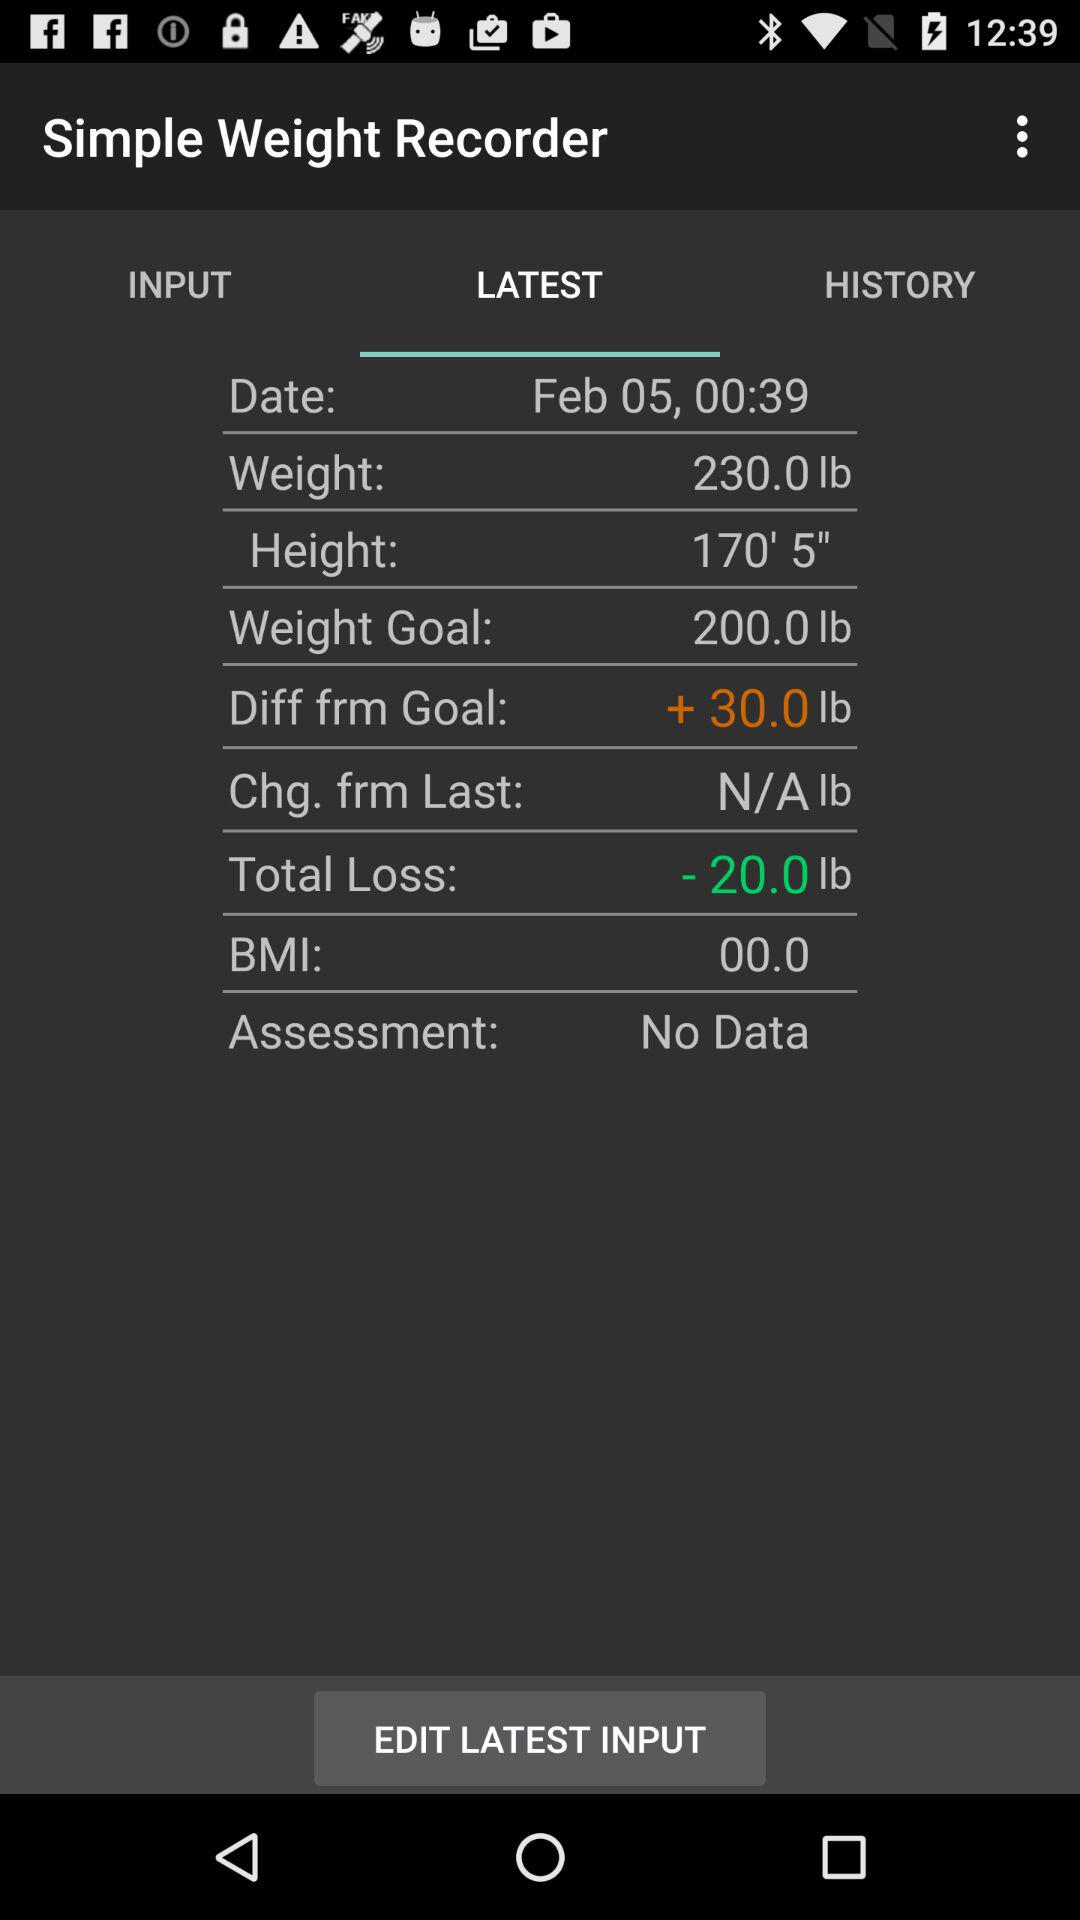What is the height of the person? The height of the person is 170′ 5″. 